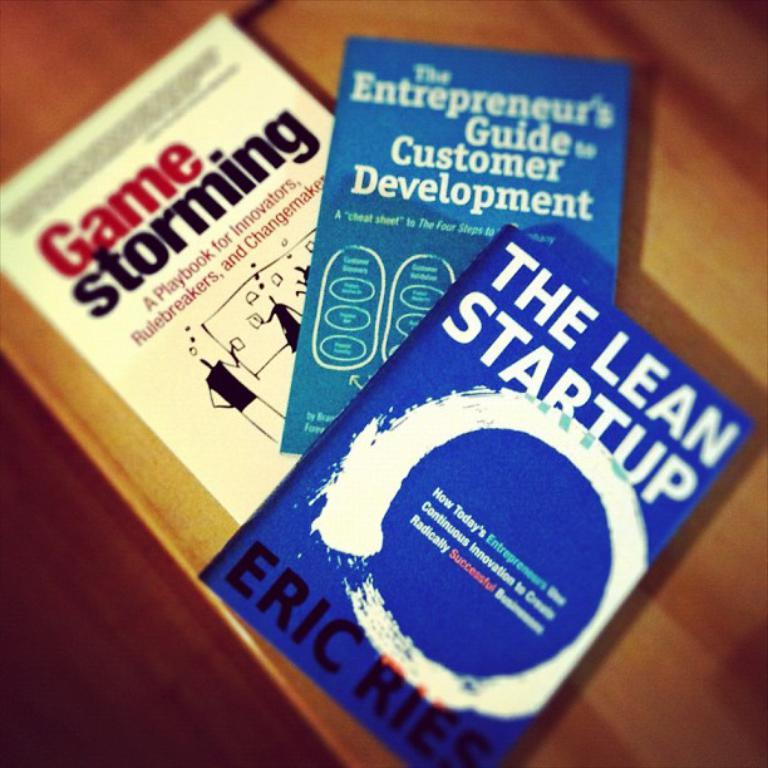<image>
Share a concise interpretation of the image provided. a book that is called The Lean Startup 